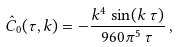Convert formula to latex. <formula><loc_0><loc_0><loc_500><loc_500>\hat { C } _ { 0 } ( \tau , k ) = - \frac { k ^ { 4 } \, \sin ( k \, \tau ) } { 9 6 0 \pi ^ { 5 } \, \tau } \, ,</formula> 